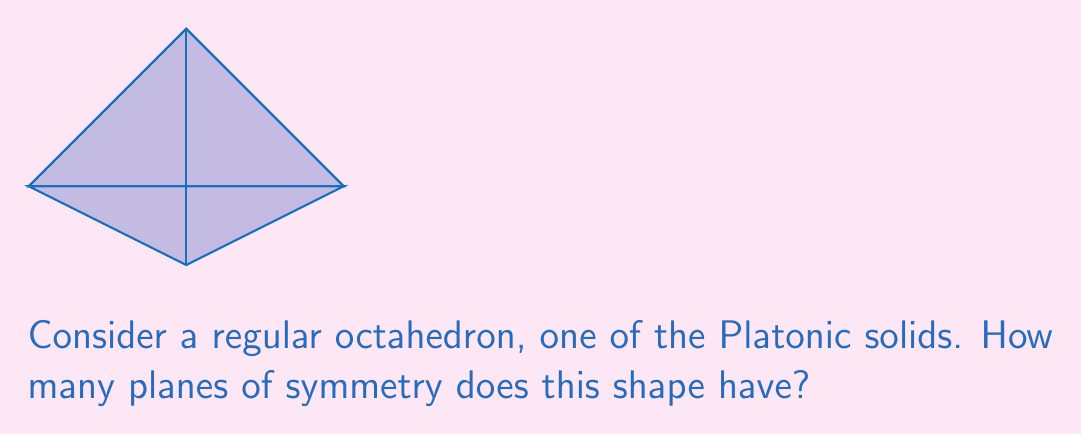Help me with this question. Let's approach this step-by-step:

1) First, recall that a plane of symmetry divides a shape into two mirror-image halves.

2) For a regular octahedron, we can identify three types of planes of symmetry:

   a) Planes passing through opposite vertices:
      There are 3 such planes, as the octahedron has 3 pairs of opposite vertices.

   b) Planes passing through the midpoints of opposite edges:
      There are 6 such planes. The octahedron has 12 edges, forming 6 pairs of opposite edges.

   c) Planes passing through the centers of opposite faces:
      There are 4 such planes. The octahedron has 8 faces, forming 4 pairs of opposite faces.

3) To visualize these planes:
   - Vertex planes bisect the octahedron through two opposite vertices.
   - Edge planes cut through the middle of four edges, creating a square cross-section.
   - Face planes pass through the centers of two opposite triangular faces.

4) To get the total number of planes of symmetry, we sum these up:

   $$ 3 + 6 + 4 = 13 $$

Therefore, a regular octahedron has 13 planes of symmetry.
Answer: 13 